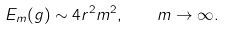<formula> <loc_0><loc_0><loc_500><loc_500>E _ { m } ( g ) \sim 4 r ^ { 2 } m ^ { 2 } , \quad m \to \infty .</formula> 